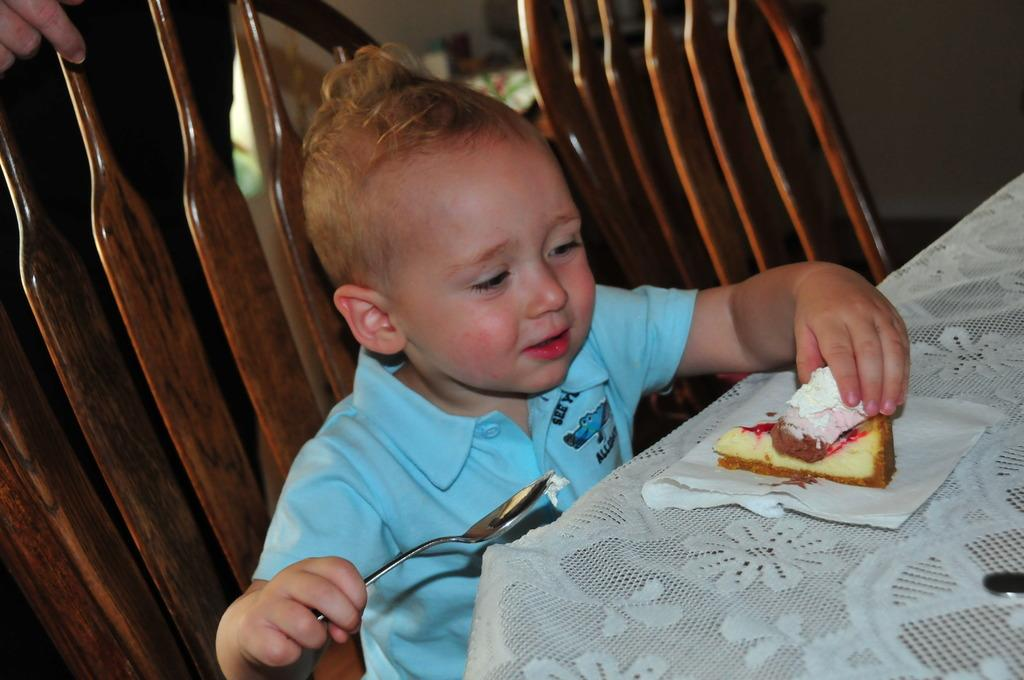What is the child in the image holding? The child is holding a spoon and a cake. What might the child be doing with the spoon and cake? The child might be about to eat the cake with the spoon. Can you see any other people in the image besides the child? Yes, there is a hand of another person visible in the background of the image. What type of apparel is the child wearing to help them slide down the slope in the image? There is no slope present in the image, and the child is not wearing any apparel specifically designed for sliding. 